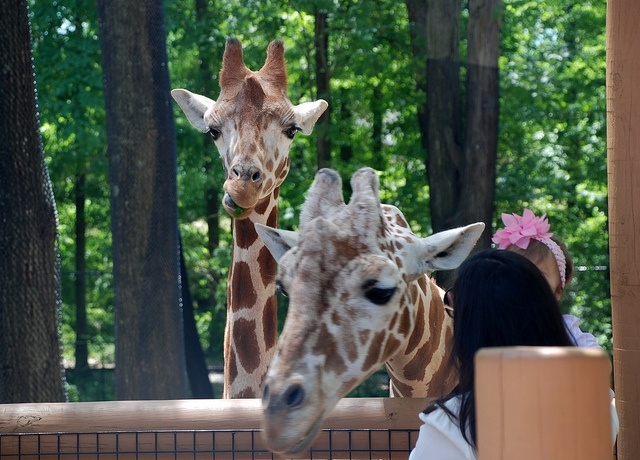Describe the objects in this image and their specific colors. I can see giraffe in black, darkgray, gray, and maroon tones, giraffe in black, darkgray, maroon, and gray tones, people in black, darkgray, and gray tones, and people in black, darkgray, gray, and violet tones in this image. 